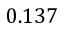Convert formula to latex. <formula><loc_0><loc_0><loc_500><loc_500>0 . 1 3 7</formula> 